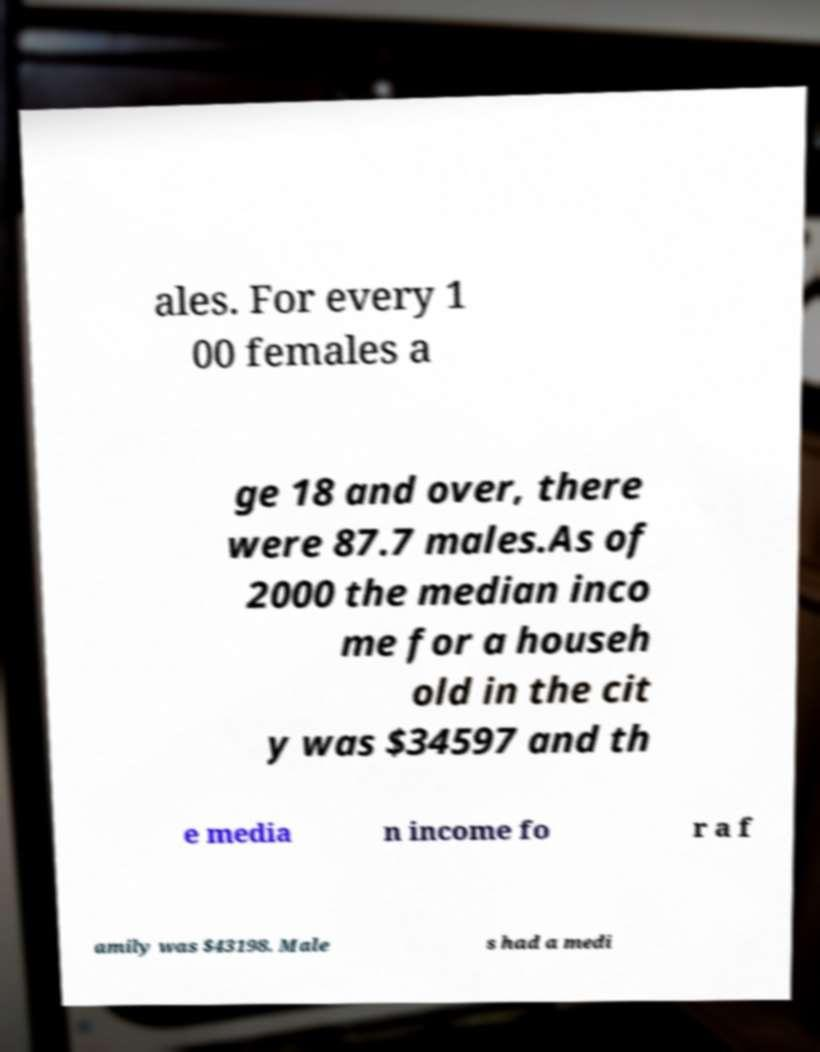There's text embedded in this image that I need extracted. Can you transcribe it verbatim? ales. For every 1 00 females a ge 18 and over, there were 87.7 males.As of 2000 the median inco me for a househ old in the cit y was $34597 and th e media n income fo r a f amily was $43198. Male s had a medi 